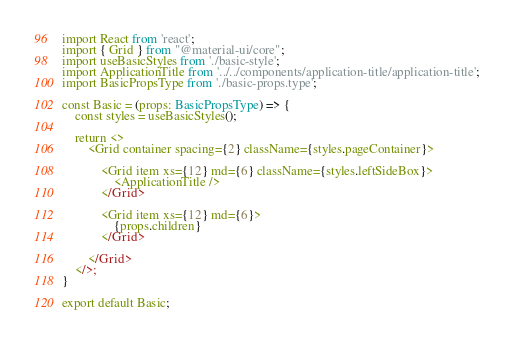Convert code to text. <code><loc_0><loc_0><loc_500><loc_500><_TypeScript_>import React from 'react';
import { Grid } from "@material-ui/core";
import useBasicStyles from './basic-style';
import ApplicationTitle from '../../components/application-title/application-title';
import BasicPropsType from './basic-props.type';

const Basic = (props: BasicPropsType) => {
    const styles = useBasicStyles();

    return <>
        <Grid container spacing={2} className={styles.pageContainer}>

            <Grid item xs={12} md={6} className={styles.leftSideBox}>
                <ApplicationTitle />
            </Grid>

            <Grid item xs={12} md={6}>
                {props.children}
            </Grid>

        </Grid>
    </>;
}

export default Basic;
</code> 